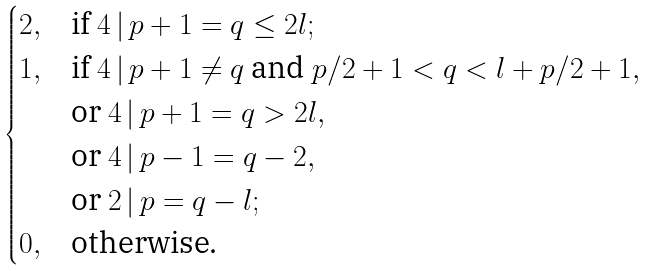<formula> <loc_0><loc_0><loc_500><loc_500>\begin{cases} 2 , & \text {if } 4 \, | \, p + 1 = q \leq 2 l ; \\ 1 , & \text {if } 4 \, | \, p + 1 \ne q \text { and } p / 2 + 1 < q < l + p / 2 + 1 , \\ & \text {or } 4 \, | \, p + 1 = q > 2 l , \\ & \text {or } 4 \, | \, p - 1 = q - 2 , \\ & \text {or } 2 \, | \, p = q - l ; \\ 0 , & \text {otherwise.} \end{cases}</formula> 